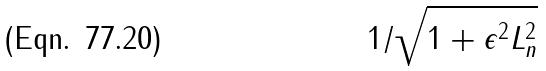<formula> <loc_0><loc_0><loc_500><loc_500>1 / \sqrt { 1 + \epsilon ^ { 2 } L _ { n } ^ { 2 } }</formula> 